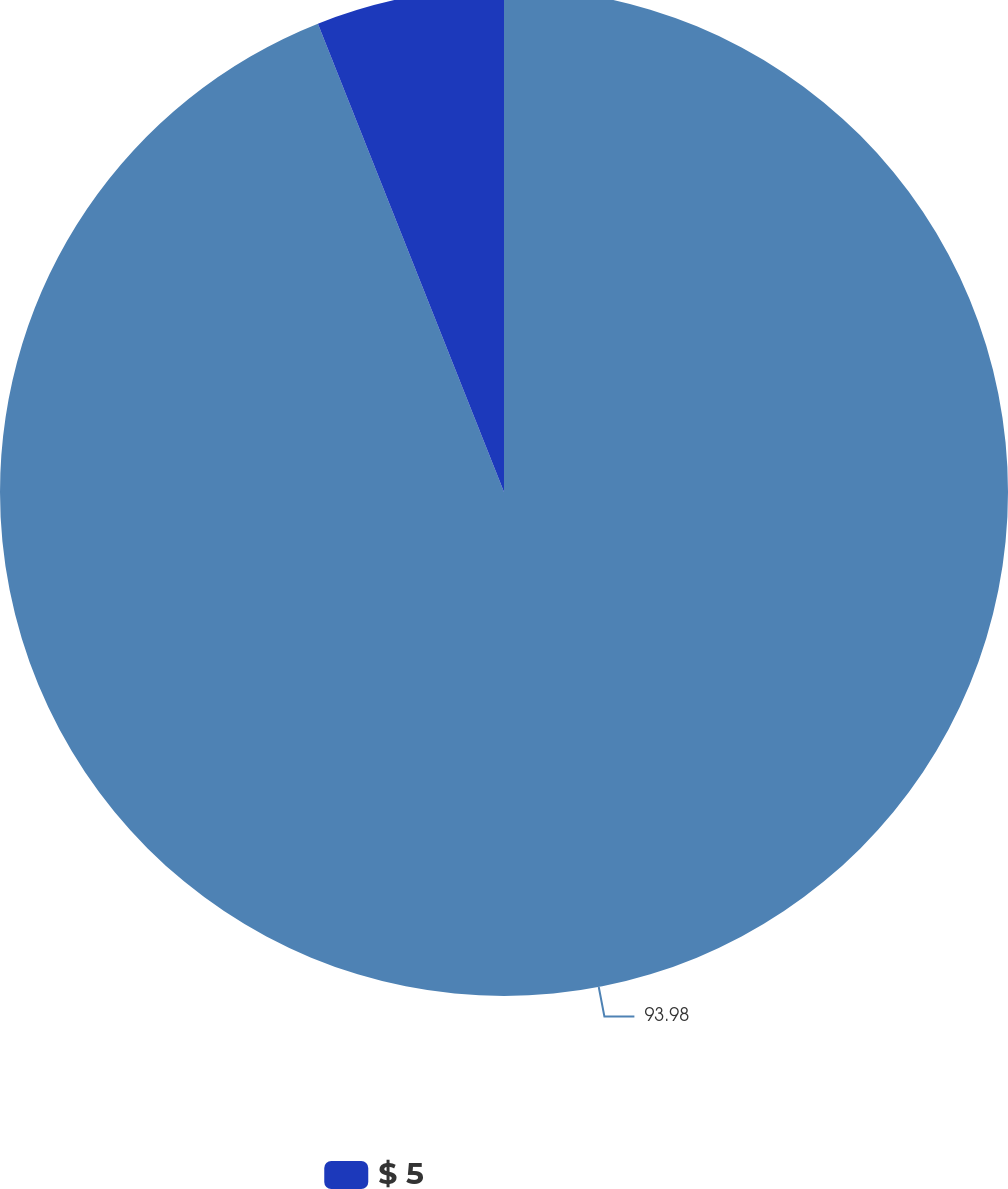Convert chart to OTSL. <chart><loc_0><loc_0><loc_500><loc_500><pie_chart><ecel><fcel>$ 5<nl><fcel>93.98%<fcel>6.02%<nl></chart> 